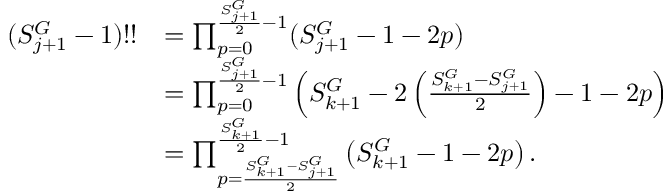<formula> <loc_0><loc_0><loc_500><loc_500>\begin{array} { r l } { ( S _ { j + 1 } ^ { G } - 1 ) ! ! } & { = \prod _ { p = 0 } ^ { \frac { S _ { j + 1 } ^ { G } } { 2 } - 1 } ( S _ { j + 1 } ^ { G } - 1 - 2 p ) } \\ & { = \prod _ { p = 0 } ^ { \frac { S _ { j + 1 } ^ { G } } { 2 } - 1 } \left ( S _ { k + 1 } ^ { G } - 2 \left ( \frac { S _ { k + 1 } ^ { G } - S _ { j + 1 } ^ { G } } { 2 } \right ) - 1 - 2 p \right ) } \\ & { = \prod _ { p = \frac { S _ { k + 1 } ^ { G } - S _ { j + 1 } ^ { G } } { 2 } } ^ { \frac { S _ { k + 1 } ^ { G } } { 2 } - 1 } \left ( S _ { k + 1 } ^ { G } - 1 - 2 p \right ) . } \end{array}</formula> 